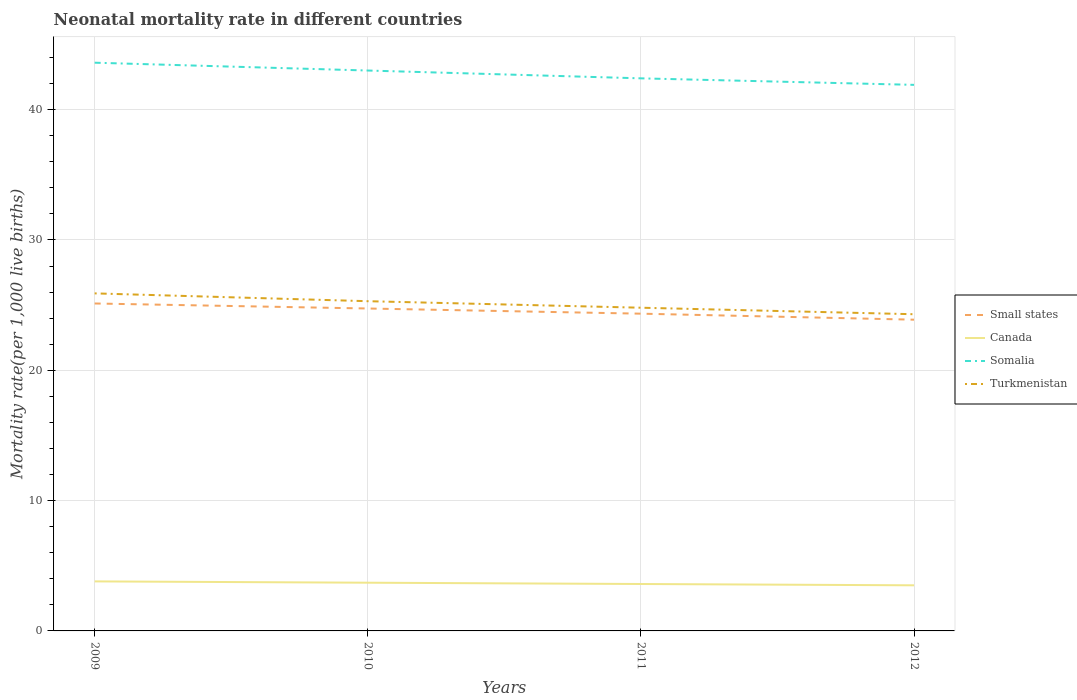Does the line corresponding to Turkmenistan intersect with the line corresponding to Small states?
Provide a succinct answer. No. Is the number of lines equal to the number of legend labels?
Your answer should be very brief. Yes. Across all years, what is the maximum neonatal mortality rate in Small states?
Keep it short and to the point. 23.88. What is the total neonatal mortality rate in Canada in the graph?
Ensure brevity in your answer.  0.1. What is the difference between the highest and the second highest neonatal mortality rate in Small states?
Your answer should be very brief. 1.24. Is the neonatal mortality rate in Small states strictly greater than the neonatal mortality rate in Canada over the years?
Offer a terse response. No. How many lines are there?
Offer a very short reply. 4. How many years are there in the graph?
Give a very brief answer. 4. Are the values on the major ticks of Y-axis written in scientific E-notation?
Provide a succinct answer. No. Does the graph contain grids?
Ensure brevity in your answer.  Yes. Where does the legend appear in the graph?
Your answer should be very brief. Center right. How many legend labels are there?
Offer a very short reply. 4. How are the legend labels stacked?
Your answer should be compact. Vertical. What is the title of the graph?
Make the answer very short. Neonatal mortality rate in different countries. Does "United Arab Emirates" appear as one of the legend labels in the graph?
Ensure brevity in your answer.  No. What is the label or title of the Y-axis?
Make the answer very short. Mortality rate(per 1,0 live births). What is the Mortality rate(per 1,000 live births) of Small states in 2009?
Your answer should be very brief. 25.12. What is the Mortality rate(per 1,000 live births) in Canada in 2009?
Provide a succinct answer. 3.8. What is the Mortality rate(per 1,000 live births) in Somalia in 2009?
Make the answer very short. 43.6. What is the Mortality rate(per 1,000 live births) of Turkmenistan in 2009?
Offer a very short reply. 25.9. What is the Mortality rate(per 1,000 live births) in Small states in 2010?
Your response must be concise. 24.74. What is the Mortality rate(per 1,000 live births) in Canada in 2010?
Offer a terse response. 3.7. What is the Mortality rate(per 1,000 live births) of Somalia in 2010?
Ensure brevity in your answer.  43. What is the Mortality rate(per 1,000 live births) of Turkmenistan in 2010?
Provide a succinct answer. 25.3. What is the Mortality rate(per 1,000 live births) in Small states in 2011?
Your response must be concise. 24.34. What is the Mortality rate(per 1,000 live births) in Canada in 2011?
Offer a very short reply. 3.6. What is the Mortality rate(per 1,000 live births) in Somalia in 2011?
Provide a succinct answer. 42.4. What is the Mortality rate(per 1,000 live births) of Turkmenistan in 2011?
Provide a succinct answer. 24.8. What is the Mortality rate(per 1,000 live births) in Small states in 2012?
Provide a short and direct response. 23.88. What is the Mortality rate(per 1,000 live births) in Somalia in 2012?
Ensure brevity in your answer.  41.9. What is the Mortality rate(per 1,000 live births) in Turkmenistan in 2012?
Your answer should be very brief. 24.3. Across all years, what is the maximum Mortality rate(per 1,000 live births) in Small states?
Provide a short and direct response. 25.12. Across all years, what is the maximum Mortality rate(per 1,000 live births) in Somalia?
Ensure brevity in your answer.  43.6. Across all years, what is the maximum Mortality rate(per 1,000 live births) in Turkmenistan?
Offer a terse response. 25.9. Across all years, what is the minimum Mortality rate(per 1,000 live births) in Small states?
Your response must be concise. 23.88. Across all years, what is the minimum Mortality rate(per 1,000 live births) of Somalia?
Your answer should be compact. 41.9. Across all years, what is the minimum Mortality rate(per 1,000 live births) in Turkmenistan?
Ensure brevity in your answer.  24.3. What is the total Mortality rate(per 1,000 live births) in Small states in the graph?
Provide a short and direct response. 98.09. What is the total Mortality rate(per 1,000 live births) of Somalia in the graph?
Your answer should be very brief. 170.9. What is the total Mortality rate(per 1,000 live births) in Turkmenistan in the graph?
Offer a terse response. 100.3. What is the difference between the Mortality rate(per 1,000 live births) in Small states in 2009 and that in 2010?
Ensure brevity in your answer.  0.38. What is the difference between the Mortality rate(per 1,000 live births) in Turkmenistan in 2009 and that in 2010?
Give a very brief answer. 0.6. What is the difference between the Mortality rate(per 1,000 live births) in Small states in 2009 and that in 2011?
Ensure brevity in your answer.  0.78. What is the difference between the Mortality rate(per 1,000 live births) in Somalia in 2009 and that in 2011?
Provide a succinct answer. 1.2. What is the difference between the Mortality rate(per 1,000 live births) of Turkmenistan in 2009 and that in 2011?
Your answer should be compact. 1.1. What is the difference between the Mortality rate(per 1,000 live births) of Small states in 2009 and that in 2012?
Your response must be concise. 1.24. What is the difference between the Mortality rate(per 1,000 live births) of Turkmenistan in 2009 and that in 2012?
Offer a very short reply. 1.6. What is the difference between the Mortality rate(per 1,000 live births) in Small states in 2010 and that in 2011?
Provide a short and direct response. 0.4. What is the difference between the Mortality rate(per 1,000 live births) in Canada in 2010 and that in 2011?
Offer a terse response. 0.1. What is the difference between the Mortality rate(per 1,000 live births) in Turkmenistan in 2010 and that in 2011?
Provide a short and direct response. 0.5. What is the difference between the Mortality rate(per 1,000 live births) of Small states in 2010 and that in 2012?
Your answer should be very brief. 0.86. What is the difference between the Mortality rate(per 1,000 live births) in Canada in 2010 and that in 2012?
Provide a short and direct response. 0.2. What is the difference between the Mortality rate(per 1,000 live births) of Turkmenistan in 2010 and that in 2012?
Give a very brief answer. 1. What is the difference between the Mortality rate(per 1,000 live births) of Small states in 2011 and that in 2012?
Offer a very short reply. 0.46. What is the difference between the Mortality rate(per 1,000 live births) of Somalia in 2011 and that in 2012?
Offer a very short reply. 0.5. What is the difference between the Mortality rate(per 1,000 live births) in Turkmenistan in 2011 and that in 2012?
Offer a terse response. 0.5. What is the difference between the Mortality rate(per 1,000 live births) of Small states in 2009 and the Mortality rate(per 1,000 live births) of Canada in 2010?
Your answer should be compact. 21.42. What is the difference between the Mortality rate(per 1,000 live births) in Small states in 2009 and the Mortality rate(per 1,000 live births) in Somalia in 2010?
Ensure brevity in your answer.  -17.88. What is the difference between the Mortality rate(per 1,000 live births) in Small states in 2009 and the Mortality rate(per 1,000 live births) in Turkmenistan in 2010?
Make the answer very short. -0.18. What is the difference between the Mortality rate(per 1,000 live births) of Canada in 2009 and the Mortality rate(per 1,000 live births) of Somalia in 2010?
Your response must be concise. -39.2. What is the difference between the Mortality rate(per 1,000 live births) of Canada in 2009 and the Mortality rate(per 1,000 live births) of Turkmenistan in 2010?
Offer a very short reply. -21.5. What is the difference between the Mortality rate(per 1,000 live births) in Small states in 2009 and the Mortality rate(per 1,000 live births) in Canada in 2011?
Make the answer very short. 21.52. What is the difference between the Mortality rate(per 1,000 live births) in Small states in 2009 and the Mortality rate(per 1,000 live births) in Somalia in 2011?
Your response must be concise. -17.28. What is the difference between the Mortality rate(per 1,000 live births) in Small states in 2009 and the Mortality rate(per 1,000 live births) in Turkmenistan in 2011?
Provide a succinct answer. 0.32. What is the difference between the Mortality rate(per 1,000 live births) of Canada in 2009 and the Mortality rate(per 1,000 live births) of Somalia in 2011?
Provide a succinct answer. -38.6. What is the difference between the Mortality rate(per 1,000 live births) in Somalia in 2009 and the Mortality rate(per 1,000 live births) in Turkmenistan in 2011?
Offer a very short reply. 18.8. What is the difference between the Mortality rate(per 1,000 live births) of Small states in 2009 and the Mortality rate(per 1,000 live births) of Canada in 2012?
Your answer should be compact. 21.62. What is the difference between the Mortality rate(per 1,000 live births) of Small states in 2009 and the Mortality rate(per 1,000 live births) of Somalia in 2012?
Provide a succinct answer. -16.78. What is the difference between the Mortality rate(per 1,000 live births) of Small states in 2009 and the Mortality rate(per 1,000 live births) of Turkmenistan in 2012?
Ensure brevity in your answer.  0.82. What is the difference between the Mortality rate(per 1,000 live births) of Canada in 2009 and the Mortality rate(per 1,000 live births) of Somalia in 2012?
Give a very brief answer. -38.1. What is the difference between the Mortality rate(per 1,000 live births) in Canada in 2009 and the Mortality rate(per 1,000 live births) in Turkmenistan in 2012?
Give a very brief answer. -20.5. What is the difference between the Mortality rate(per 1,000 live births) of Somalia in 2009 and the Mortality rate(per 1,000 live births) of Turkmenistan in 2012?
Make the answer very short. 19.3. What is the difference between the Mortality rate(per 1,000 live births) in Small states in 2010 and the Mortality rate(per 1,000 live births) in Canada in 2011?
Give a very brief answer. 21.14. What is the difference between the Mortality rate(per 1,000 live births) of Small states in 2010 and the Mortality rate(per 1,000 live births) of Somalia in 2011?
Provide a succinct answer. -17.66. What is the difference between the Mortality rate(per 1,000 live births) in Small states in 2010 and the Mortality rate(per 1,000 live births) in Turkmenistan in 2011?
Offer a terse response. -0.06. What is the difference between the Mortality rate(per 1,000 live births) in Canada in 2010 and the Mortality rate(per 1,000 live births) in Somalia in 2011?
Give a very brief answer. -38.7. What is the difference between the Mortality rate(per 1,000 live births) in Canada in 2010 and the Mortality rate(per 1,000 live births) in Turkmenistan in 2011?
Make the answer very short. -21.1. What is the difference between the Mortality rate(per 1,000 live births) in Small states in 2010 and the Mortality rate(per 1,000 live births) in Canada in 2012?
Make the answer very short. 21.24. What is the difference between the Mortality rate(per 1,000 live births) of Small states in 2010 and the Mortality rate(per 1,000 live births) of Somalia in 2012?
Your response must be concise. -17.16. What is the difference between the Mortality rate(per 1,000 live births) of Small states in 2010 and the Mortality rate(per 1,000 live births) of Turkmenistan in 2012?
Your answer should be compact. 0.44. What is the difference between the Mortality rate(per 1,000 live births) in Canada in 2010 and the Mortality rate(per 1,000 live births) in Somalia in 2012?
Provide a succinct answer. -38.2. What is the difference between the Mortality rate(per 1,000 live births) in Canada in 2010 and the Mortality rate(per 1,000 live births) in Turkmenistan in 2012?
Give a very brief answer. -20.6. What is the difference between the Mortality rate(per 1,000 live births) in Small states in 2011 and the Mortality rate(per 1,000 live births) in Canada in 2012?
Provide a succinct answer. 20.84. What is the difference between the Mortality rate(per 1,000 live births) of Small states in 2011 and the Mortality rate(per 1,000 live births) of Somalia in 2012?
Offer a terse response. -17.56. What is the difference between the Mortality rate(per 1,000 live births) in Small states in 2011 and the Mortality rate(per 1,000 live births) in Turkmenistan in 2012?
Your answer should be compact. 0.04. What is the difference between the Mortality rate(per 1,000 live births) in Canada in 2011 and the Mortality rate(per 1,000 live births) in Somalia in 2012?
Offer a terse response. -38.3. What is the difference between the Mortality rate(per 1,000 live births) of Canada in 2011 and the Mortality rate(per 1,000 live births) of Turkmenistan in 2012?
Make the answer very short. -20.7. What is the average Mortality rate(per 1,000 live births) of Small states per year?
Offer a very short reply. 24.52. What is the average Mortality rate(per 1,000 live births) in Canada per year?
Your answer should be compact. 3.65. What is the average Mortality rate(per 1,000 live births) in Somalia per year?
Make the answer very short. 42.73. What is the average Mortality rate(per 1,000 live births) of Turkmenistan per year?
Keep it short and to the point. 25.07. In the year 2009, what is the difference between the Mortality rate(per 1,000 live births) of Small states and Mortality rate(per 1,000 live births) of Canada?
Ensure brevity in your answer.  21.32. In the year 2009, what is the difference between the Mortality rate(per 1,000 live births) in Small states and Mortality rate(per 1,000 live births) in Somalia?
Your answer should be compact. -18.48. In the year 2009, what is the difference between the Mortality rate(per 1,000 live births) of Small states and Mortality rate(per 1,000 live births) of Turkmenistan?
Offer a very short reply. -0.78. In the year 2009, what is the difference between the Mortality rate(per 1,000 live births) of Canada and Mortality rate(per 1,000 live births) of Somalia?
Your answer should be compact. -39.8. In the year 2009, what is the difference between the Mortality rate(per 1,000 live births) in Canada and Mortality rate(per 1,000 live births) in Turkmenistan?
Your answer should be compact. -22.1. In the year 2010, what is the difference between the Mortality rate(per 1,000 live births) in Small states and Mortality rate(per 1,000 live births) in Canada?
Offer a very short reply. 21.04. In the year 2010, what is the difference between the Mortality rate(per 1,000 live births) in Small states and Mortality rate(per 1,000 live births) in Somalia?
Provide a succinct answer. -18.26. In the year 2010, what is the difference between the Mortality rate(per 1,000 live births) of Small states and Mortality rate(per 1,000 live births) of Turkmenistan?
Keep it short and to the point. -0.56. In the year 2010, what is the difference between the Mortality rate(per 1,000 live births) of Canada and Mortality rate(per 1,000 live births) of Somalia?
Keep it short and to the point. -39.3. In the year 2010, what is the difference between the Mortality rate(per 1,000 live births) in Canada and Mortality rate(per 1,000 live births) in Turkmenistan?
Your answer should be compact. -21.6. In the year 2010, what is the difference between the Mortality rate(per 1,000 live births) in Somalia and Mortality rate(per 1,000 live births) in Turkmenistan?
Your answer should be very brief. 17.7. In the year 2011, what is the difference between the Mortality rate(per 1,000 live births) in Small states and Mortality rate(per 1,000 live births) in Canada?
Ensure brevity in your answer.  20.74. In the year 2011, what is the difference between the Mortality rate(per 1,000 live births) in Small states and Mortality rate(per 1,000 live births) in Somalia?
Your response must be concise. -18.06. In the year 2011, what is the difference between the Mortality rate(per 1,000 live births) of Small states and Mortality rate(per 1,000 live births) of Turkmenistan?
Your answer should be compact. -0.46. In the year 2011, what is the difference between the Mortality rate(per 1,000 live births) in Canada and Mortality rate(per 1,000 live births) in Somalia?
Give a very brief answer. -38.8. In the year 2011, what is the difference between the Mortality rate(per 1,000 live births) in Canada and Mortality rate(per 1,000 live births) in Turkmenistan?
Your response must be concise. -21.2. In the year 2012, what is the difference between the Mortality rate(per 1,000 live births) of Small states and Mortality rate(per 1,000 live births) of Canada?
Ensure brevity in your answer.  20.38. In the year 2012, what is the difference between the Mortality rate(per 1,000 live births) in Small states and Mortality rate(per 1,000 live births) in Somalia?
Ensure brevity in your answer.  -18.02. In the year 2012, what is the difference between the Mortality rate(per 1,000 live births) in Small states and Mortality rate(per 1,000 live births) in Turkmenistan?
Give a very brief answer. -0.42. In the year 2012, what is the difference between the Mortality rate(per 1,000 live births) of Canada and Mortality rate(per 1,000 live births) of Somalia?
Ensure brevity in your answer.  -38.4. In the year 2012, what is the difference between the Mortality rate(per 1,000 live births) in Canada and Mortality rate(per 1,000 live births) in Turkmenistan?
Give a very brief answer. -20.8. In the year 2012, what is the difference between the Mortality rate(per 1,000 live births) of Somalia and Mortality rate(per 1,000 live births) of Turkmenistan?
Provide a short and direct response. 17.6. What is the ratio of the Mortality rate(per 1,000 live births) in Small states in 2009 to that in 2010?
Your answer should be very brief. 1.02. What is the ratio of the Mortality rate(per 1,000 live births) in Turkmenistan in 2009 to that in 2010?
Your answer should be very brief. 1.02. What is the ratio of the Mortality rate(per 1,000 live births) of Small states in 2009 to that in 2011?
Offer a terse response. 1.03. What is the ratio of the Mortality rate(per 1,000 live births) of Canada in 2009 to that in 2011?
Ensure brevity in your answer.  1.06. What is the ratio of the Mortality rate(per 1,000 live births) of Somalia in 2009 to that in 2011?
Provide a succinct answer. 1.03. What is the ratio of the Mortality rate(per 1,000 live births) of Turkmenistan in 2009 to that in 2011?
Your answer should be compact. 1.04. What is the ratio of the Mortality rate(per 1,000 live births) of Small states in 2009 to that in 2012?
Your answer should be compact. 1.05. What is the ratio of the Mortality rate(per 1,000 live births) of Canada in 2009 to that in 2012?
Make the answer very short. 1.09. What is the ratio of the Mortality rate(per 1,000 live births) of Somalia in 2009 to that in 2012?
Give a very brief answer. 1.04. What is the ratio of the Mortality rate(per 1,000 live births) of Turkmenistan in 2009 to that in 2012?
Your answer should be compact. 1.07. What is the ratio of the Mortality rate(per 1,000 live births) in Small states in 2010 to that in 2011?
Provide a short and direct response. 1.02. What is the ratio of the Mortality rate(per 1,000 live births) of Canada in 2010 to that in 2011?
Make the answer very short. 1.03. What is the ratio of the Mortality rate(per 1,000 live births) in Somalia in 2010 to that in 2011?
Your answer should be very brief. 1.01. What is the ratio of the Mortality rate(per 1,000 live births) of Turkmenistan in 2010 to that in 2011?
Offer a terse response. 1.02. What is the ratio of the Mortality rate(per 1,000 live births) in Small states in 2010 to that in 2012?
Make the answer very short. 1.04. What is the ratio of the Mortality rate(per 1,000 live births) of Canada in 2010 to that in 2012?
Ensure brevity in your answer.  1.06. What is the ratio of the Mortality rate(per 1,000 live births) of Somalia in 2010 to that in 2012?
Offer a very short reply. 1.03. What is the ratio of the Mortality rate(per 1,000 live births) of Turkmenistan in 2010 to that in 2012?
Ensure brevity in your answer.  1.04. What is the ratio of the Mortality rate(per 1,000 live births) of Small states in 2011 to that in 2012?
Your answer should be compact. 1.02. What is the ratio of the Mortality rate(per 1,000 live births) in Canada in 2011 to that in 2012?
Provide a succinct answer. 1.03. What is the ratio of the Mortality rate(per 1,000 live births) of Somalia in 2011 to that in 2012?
Keep it short and to the point. 1.01. What is the ratio of the Mortality rate(per 1,000 live births) of Turkmenistan in 2011 to that in 2012?
Offer a terse response. 1.02. What is the difference between the highest and the second highest Mortality rate(per 1,000 live births) of Small states?
Provide a short and direct response. 0.38. What is the difference between the highest and the second highest Mortality rate(per 1,000 live births) of Somalia?
Your answer should be compact. 0.6. What is the difference between the highest and the second highest Mortality rate(per 1,000 live births) of Turkmenistan?
Give a very brief answer. 0.6. What is the difference between the highest and the lowest Mortality rate(per 1,000 live births) in Small states?
Your answer should be compact. 1.24. 